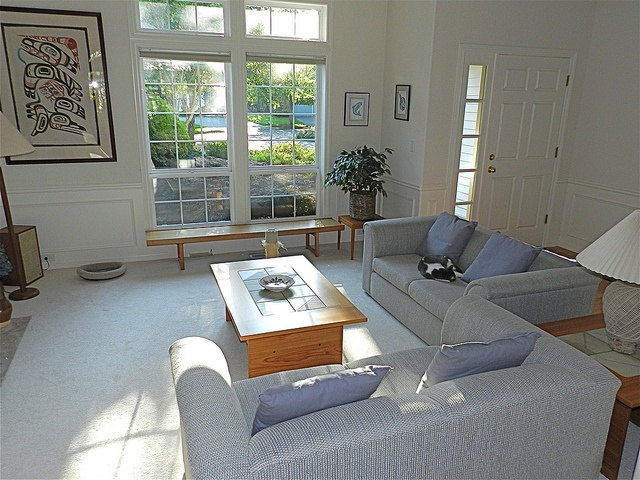Describe the objects in this image and their specific colors. I can see couch in gray, darkgray, and white tones, couch in gray and black tones, dining table in gray, white, brown, darkgray, and maroon tones, potted plant in gray, black, and darkgray tones, and bench in gray, darkgray, and maroon tones in this image. 